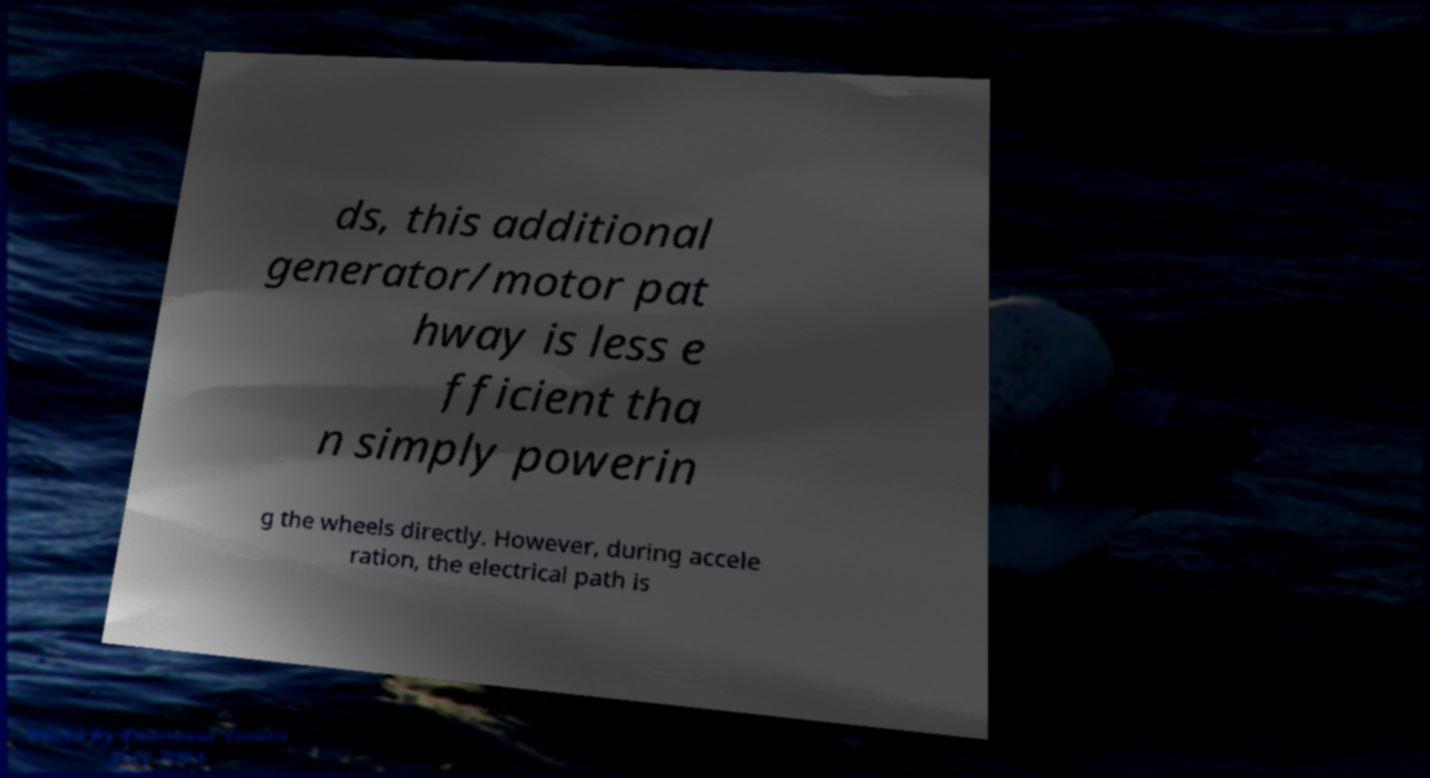Please identify and transcribe the text found in this image. ds, this additional generator/motor pat hway is less e fficient tha n simply powerin g the wheels directly. However, during accele ration, the electrical path is 